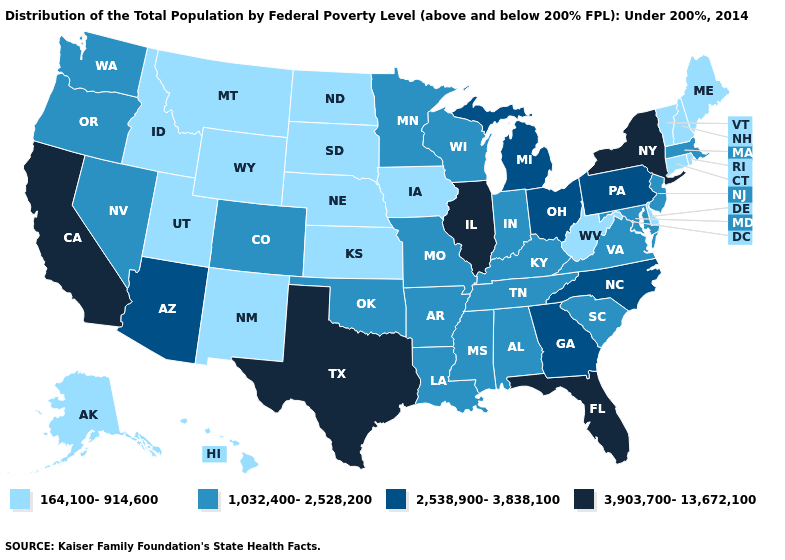Is the legend a continuous bar?
Be succinct. No. What is the value of New Hampshire?
Quick response, please. 164,100-914,600. Does Arizona have a lower value than Kansas?
Keep it brief. No. What is the value of Minnesota?
Be succinct. 1,032,400-2,528,200. Name the states that have a value in the range 3,903,700-13,672,100?
Be succinct. California, Florida, Illinois, New York, Texas. Which states hav the highest value in the Northeast?
Give a very brief answer. New York. What is the value of Hawaii?
Write a very short answer. 164,100-914,600. Does the map have missing data?
Concise answer only. No. Name the states that have a value in the range 2,538,900-3,838,100?
Be succinct. Arizona, Georgia, Michigan, North Carolina, Ohio, Pennsylvania. What is the lowest value in the USA?
Quick response, please. 164,100-914,600. Among the states that border New Mexico , does Utah have the lowest value?
Answer briefly. Yes. What is the value of Maine?
Quick response, please. 164,100-914,600. Does Maine have the highest value in the Northeast?
Answer briefly. No. What is the highest value in the Northeast ?
Write a very short answer. 3,903,700-13,672,100. Name the states that have a value in the range 2,538,900-3,838,100?
Write a very short answer. Arizona, Georgia, Michigan, North Carolina, Ohio, Pennsylvania. 